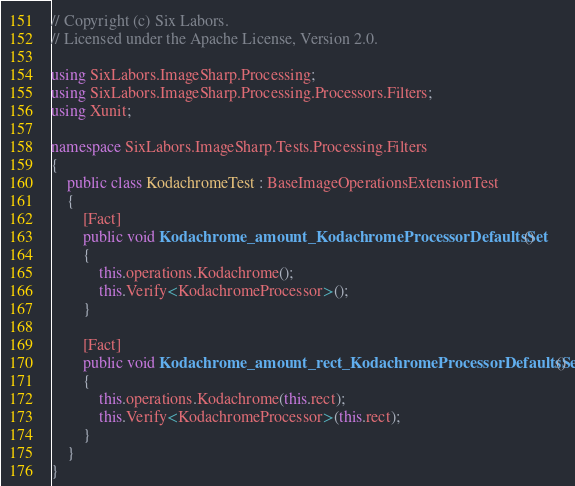<code> <loc_0><loc_0><loc_500><loc_500><_C#_>// Copyright (c) Six Labors.
// Licensed under the Apache License, Version 2.0.

using SixLabors.ImageSharp.Processing;
using SixLabors.ImageSharp.Processing.Processors.Filters;
using Xunit;

namespace SixLabors.ImageSharp.Tests.Processing.Filters
{
    public class KodachromeTest : BaseImageOperationsExtensionTest
    {
        [Fact]
        public void Kodachrome_amount_KodachromeProcessorDefaultsSet()
        {
            this.operations.Kodachrome();
            this.Verify<KodachromeProcessor>();
        }

        [Fact]
        public void Kodachrome_amount_rect_KodachromeProcessorDefaultsSet()
        {
            this.operations.Kodachrome(this.rect);
            this.Verify<KodachromeProcessor>(this.rect);
        }
    }
}
</code> 